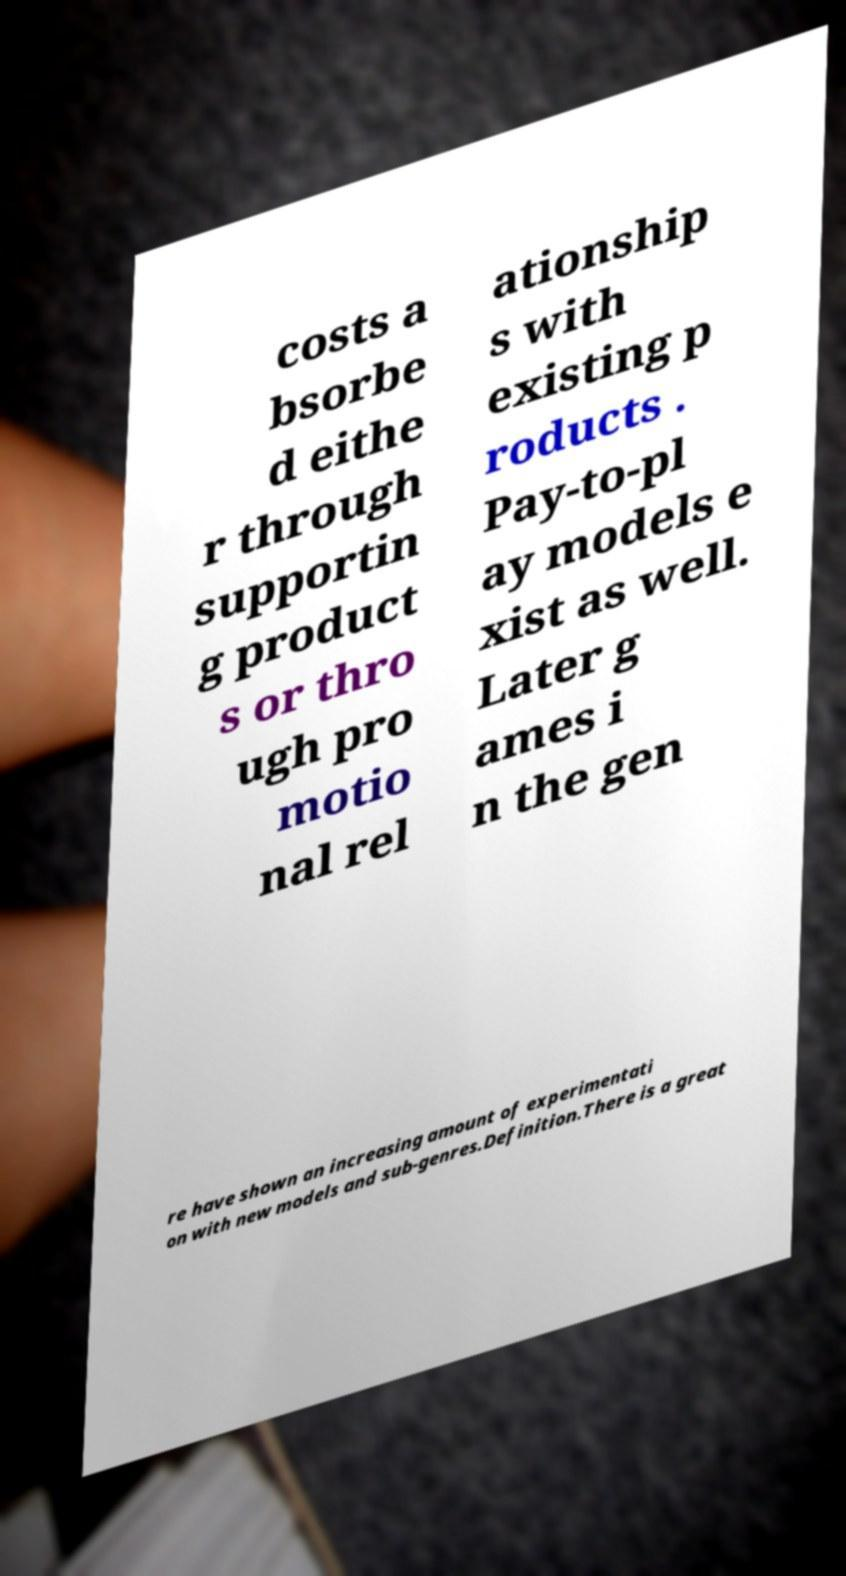What messages or text are displayed in this image? I need them in a readable, typed format. costs a bsorbe d eithe r through supportin g product s or thro ugh pro motio nal rel ationship s with existing p roducts . Pay-to-pl ay models e xist as well. Later g ames i n the gen re have shown an increasing amount of experimentati on with new models and sub-genres.Definition.There is a great 